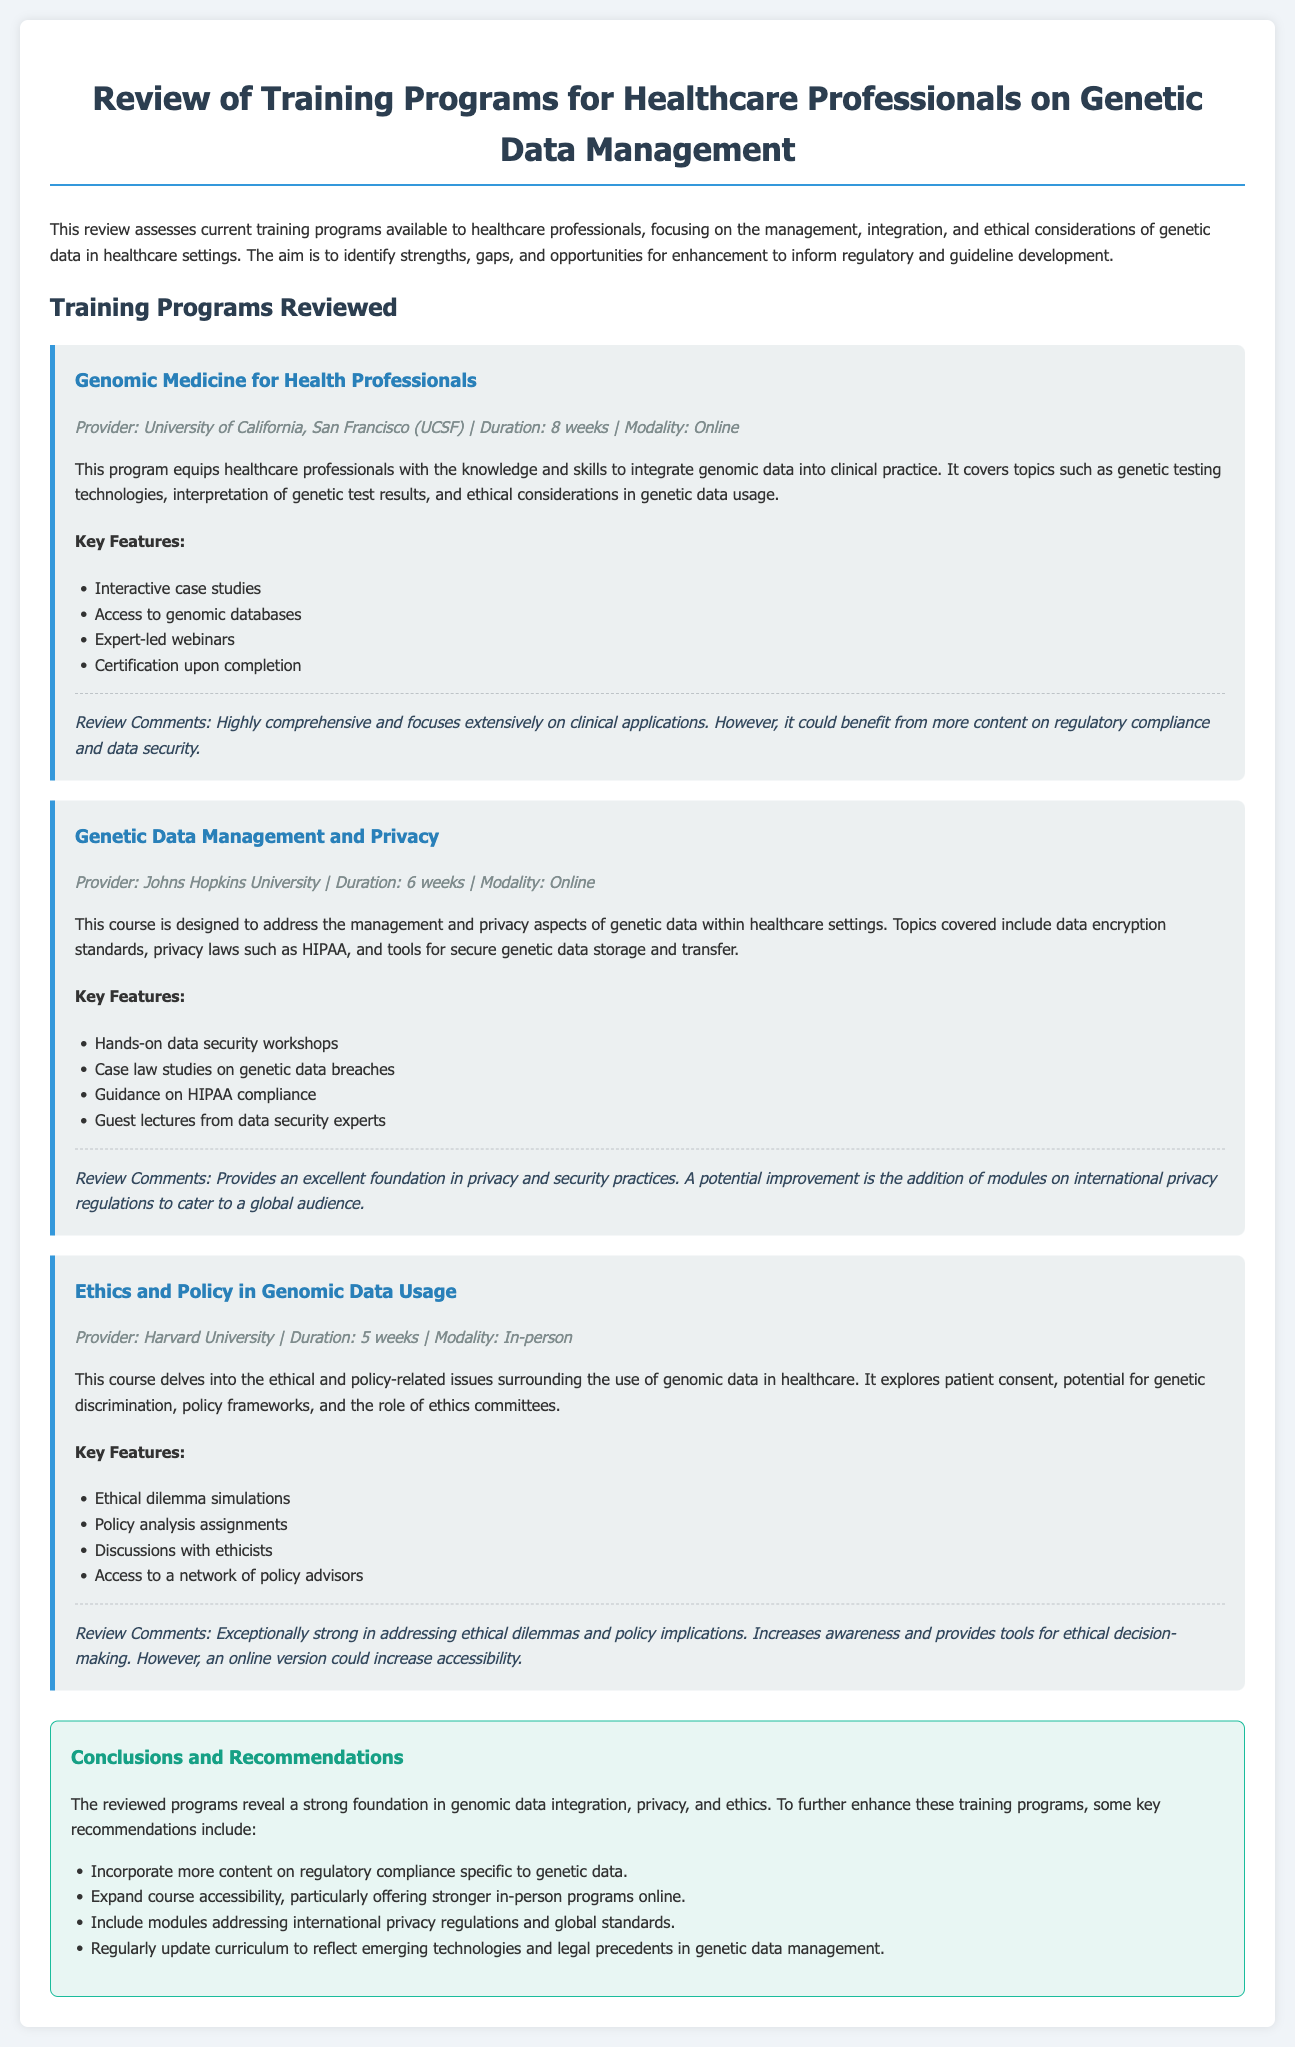what is the duration of the program "Genomic Medicine for Health Professionals"? The duration of the program is mentioned explicitly in the document, which states that it is 8 weeks.
Answer: 8 weeks who is the provider of the program "Genetic Data Management and Privacy"? The provider for the program "Genetic Data Management and Privacy" is stated as Johns Hopkins University.
Answer: Johns Hopkins University how many weeks does the "Ethics and Policy in Genomic Data Usage" course last? The duration of the "Ethics and Policy in Genomic Data Usage" course is explicitly noted as 5 weeks.
Answer: 5 weeks what is one key feature of the "Genomic Medicine for Health Professionals" program? A key feature of this program listed in the document is "Interactive case studies."
Answer: Interactive case studies what aspect could the "Genomic Medicine for Health Professionals" program benefit from according to review comments? The review comments indicate that the program could benefit from more content on regulatory compliance and data security.
Answer: More content on regulatory compliance and data security what type of modality is the "Ethics and Policy in Genomic Data Usage" course offered? The document specifies that this course is offered as an in-person modality.
Answer: In-person what is a recommendation made in the appraisal form? The appraisal form includes recommendations such as to incorporate more content on regulatory compliance specific to genetic data.
Answer: Incorporate more content on regulatory compliance specific to genetic data what is the key focus of the reviewed training programs? The key focus is on the management, integration, and ethical considerations of genetic data in healthcare settings.
Answer: Management, integration, and ethical considerations of genetic data in healthcare settings what is one potential improvement for the "Genetic Data Management and Privacy" course? A potential improvement mentioned is the addition of modules on international privacy regulations to cater to a global audience.
Answer: Addition of modules on international privacy regulations 